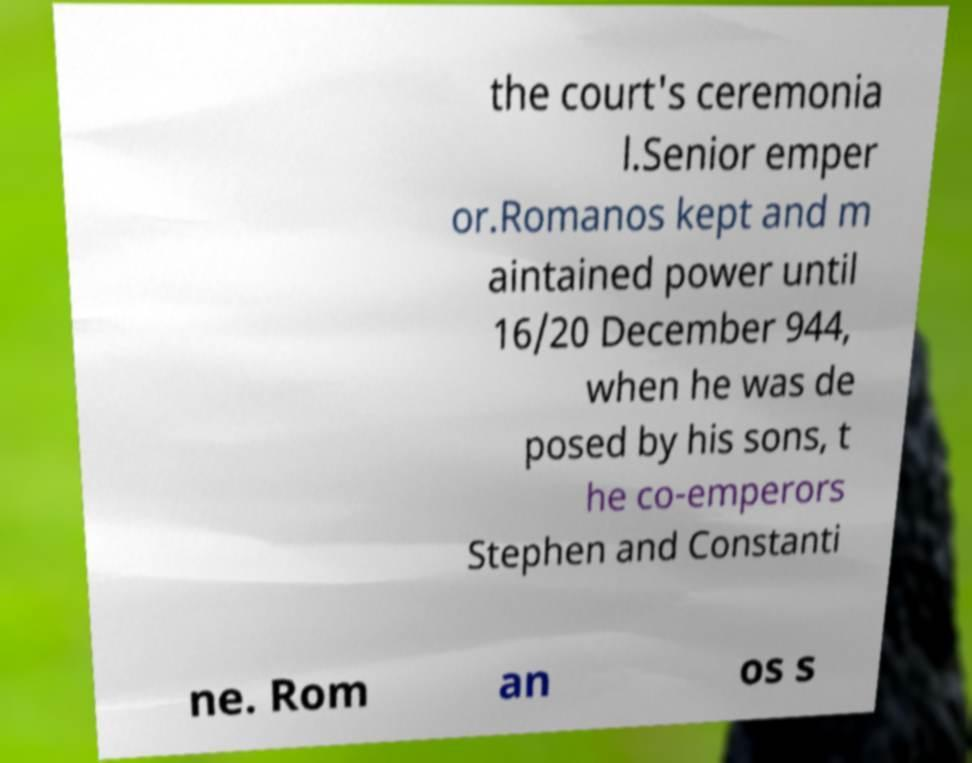Can you read and provide the text displayed in the image?This photo seems to have some interesting text. Can you extract and type it out for me? the court's ceremonia l.Senior emper or.Romanos kept and m aintained power until 16/20 December 944, when he was de posed by his sons, t he co-emperors Stephen and Constanti ne. Rom an os s 